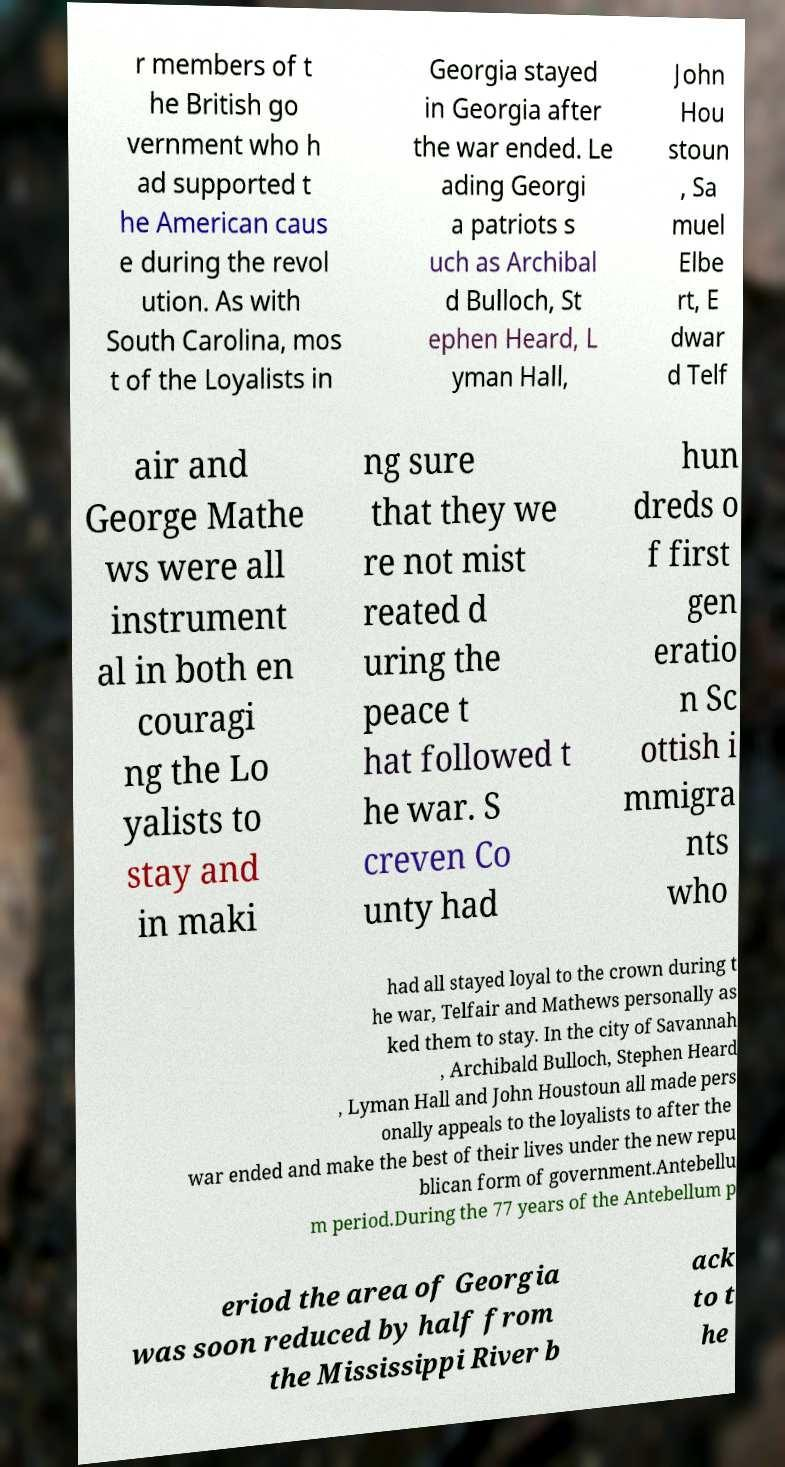Please read and relay the text visible in this image. What does it say? r members of t he British go vernment who h ad supported t he American caus e during the revol ution. As with South Carolina, mos t of the Loyalists in Georgia stayed in Georgia after the war ended. Le ading Georgi a patriots s uch as Archibal d Bulloch, St ephen Heard, L yman Hall, John Hou stoun , Sa muel Elbe rt, E dwar d Telf air and George Mathe ws were all instrument al in both en couragi ng the Lo yalists to stay and in maki ng sure that they we re not mist reated d uring the peace t hat followed t he war. S creven Co unty had hun dreds o f first gen eratio n Sc ottish i mmigra nts who had all stayed loyal to the crown during t he war, Telfair and Mathews personally as ked them to stay. In the city of Savannah , Archibald Bulloch, Stephen Heard , Lyman Hall and John Houstoun all made pers onally appeals to the loyalists to after the war ended and make the best of their lives under the new repu blican form of government.Antebellu m period.During the 77 years of the Antebellum p eriod the area of Georgia was soon reduced by half from the Mississippi River b ack to t he 